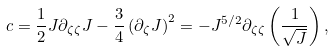Convert formula to latex. <formula><loc_0><loc_0><loc_500><loc_500>c = \frac { 1 } { 2 } J \partial _ { \zeta \zeta } J - \frac { 3 } { 4 } \left ( \partial _ { \zeta } J \right ) ^ { 2 } = - J ^ { 5 / 2 } \partial _ { \zeta \zeta } \left ( \frac { 1 } { \sqrt { J } } \right ) ,</formula> 